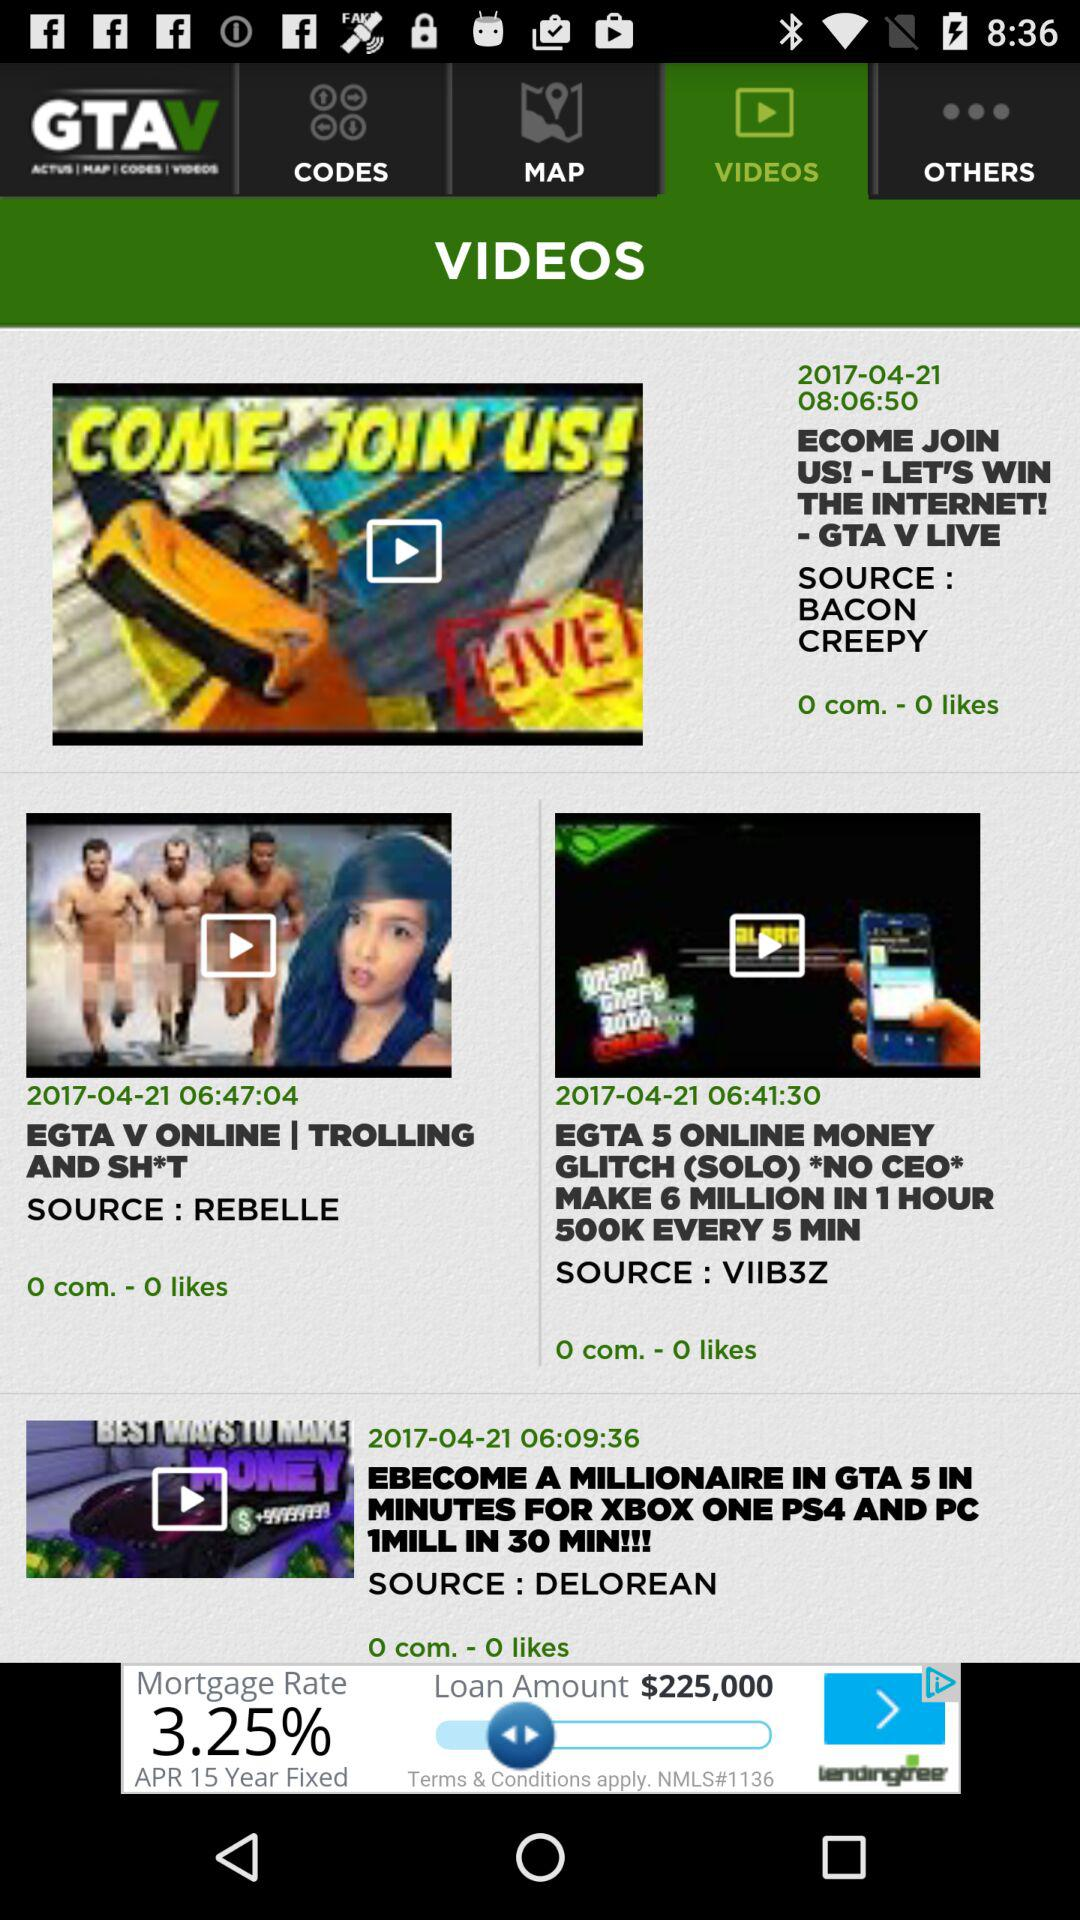What is the published date of the video named "ECOME JOIN US!"? The published date of the video is April 21, 2017. 